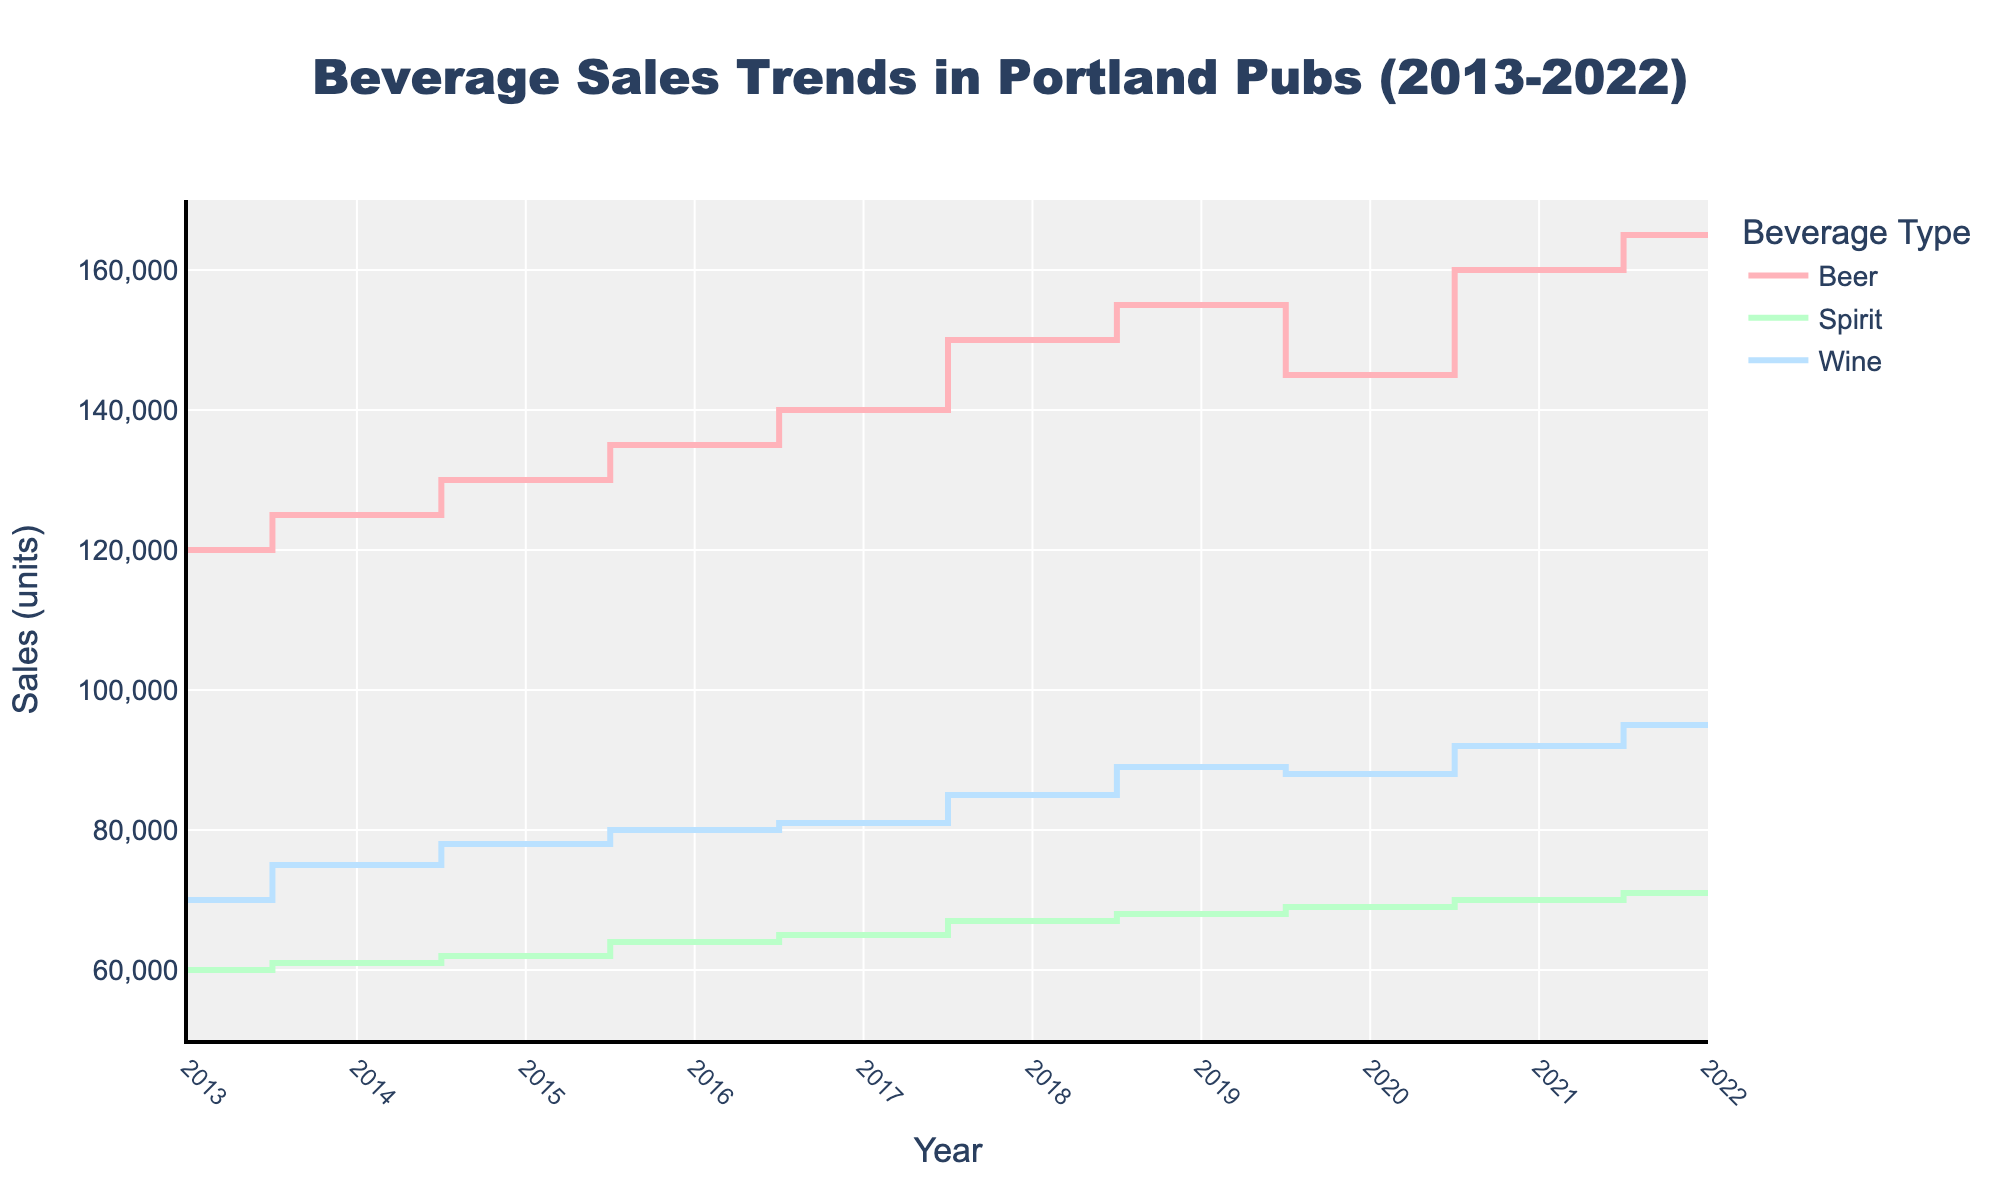What is the title of the chart? The title is displayed prominently at the top of the chart. It reads: "Beverage Sales Trends in Portland Pubs (2013-2022)".
Answer: Beverage Sales Trends in Portland Pubs (2013-2022) What are the axes labeled in the figure? The x-axis represents time and is labeled "Year", while the y-axis represents sales units and is labeled "Sales (units)".
Answer: Year (x-axis) and Sales (units) (y-axis) How many beverage types are plotted in the figure? The legend shows three beverage types: Beer, Spirits, and Wine.
Answer: 3 When did Beer sales experience a decline? The line representing Beer sales drops between 2019 and 2020.
Answer: Between 2019 and 2020 Which beverage had the highest sales in 2022? By looking at the endpoints of the lines in 2022, Beer has the highest sales.
Answer: Beer What was the trend for Spirit sales from 2013 to 2022? The overall trend for Spirit sales is consistently increasing over the time period, without any declines.
Answer: Consistently increasing How much did Wine sales increase from 2013 to 2022? Wine sales increased from 70,000 units in 2013 to 95,000 units in 2022, which is a difference of 25,000 units.
Answer: 25,000 units Which beverage type showed the greatest increase in sales over the entire period? Based on the start and end points of the lines, Beer sales increased from 120,000 to 165,000 units, which is an increase of 45,000 units, higher than the other beverages.
Answer: Beer In how many years did Beer and Wine sales increase simultaneously? Both Beer and Wine sales lines show an increase from the previous year in 2014, 2015, 2016, 2017, 2018, 2019, 2021, and 2022.
Answer: 8 years By how much did Spirit sales increase between 2013 and 2016? Spirit sales increased from 60,000 units in 2013 to 64,000 units in 2016, so the increase is 4,000 units.
Answer: 4,000 units 